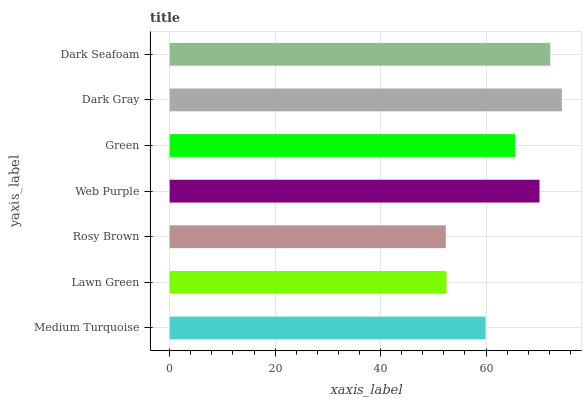Is Rosy Brown the minimum?
Answer yes or no. Yes. Is Dark Gray the maximum?
Answer yes or no. Yes. Is Lawn Green the minimum?
Answer yes or no. No. Is Lawn Green the maximum?
Answer yes or no. No. Is Medium Turquoise greater than Lawn Green?
Answer yes or no. Yes. Is Lawn Green less than Medium Turquoise?
Answer yes or no. Yes. Is Lawn Green greater than Medium Turquoise?
Answer yes or no. No. Is Medium Turquoise less than Lawn Green?
Answer yes or no. No. Is Green the high median?
Answer yes or no. Yes. Is Green the low median?
Answer yes or no. Yes. Is Rosy Brown the high median?
Answer yes or no. No. Is Web Purple the low median?
Answer yes or no. No. 